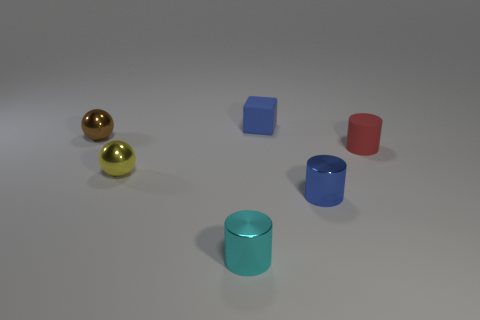There is a red thing that is the same shape as the cyan object; what material is it?
Offer a terse response. Rubber. Is the number of big spheres greater than the number of objects?
Make the answer very short. No. Does the rubber cube have the same color as the small metallic object on the right side of the tiny cyan shiny thing?
Offer a terse response. Yes. There is a small object that is behind the red thing and to the right of the small brown metal ball; what is its color?
Your response must be concise. Blue. How many other things are there of the same material as the yellow object?
Your response must be concise. 3. Is the number of cyan metal cylinders less than the number of small blue objects?
Your answer should be very brief. Yes. Do the cyan cylinder and the tiny sphere behind the red cylinder have the same material?
Keep it short and to the point. Yes. What shape is the rubber thing that is to the right of the tiny blue matte thing?
Your answer should be compact. Cylinder. Is there any other thing of the same color as the tiny cube?
Your response must be concise. Yes. Is the number of small yellow things to the right of the tiny yellow shiny sphere less than the number of purple shiny cubes?
Give a very brief answer. No. 